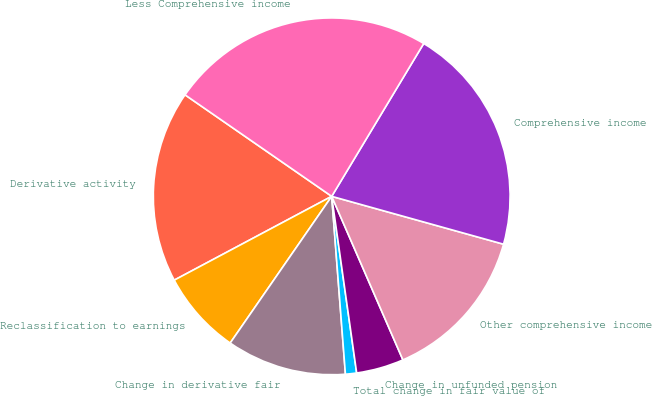<chart> <loc_0><loc_0><loc_500><loc_500><pie_chart><fcel>Derivative activity<fcel>Reclassification to earnings<fcel>Change in derivative fair<fcel>Total change in fair value of<fcel>Change in unfunded pension<fcel>Other comprehensive income<fcel>Comprehensive income<fcel>Less Comprehensive income<nl><fcel>17.42%<fcel>7.58%<fcel>10.86%<fcel>1.01%<fcel>4.3%<fcel>14.14%<fcel>20.7%<fcel>23.99%<nl></chart> 